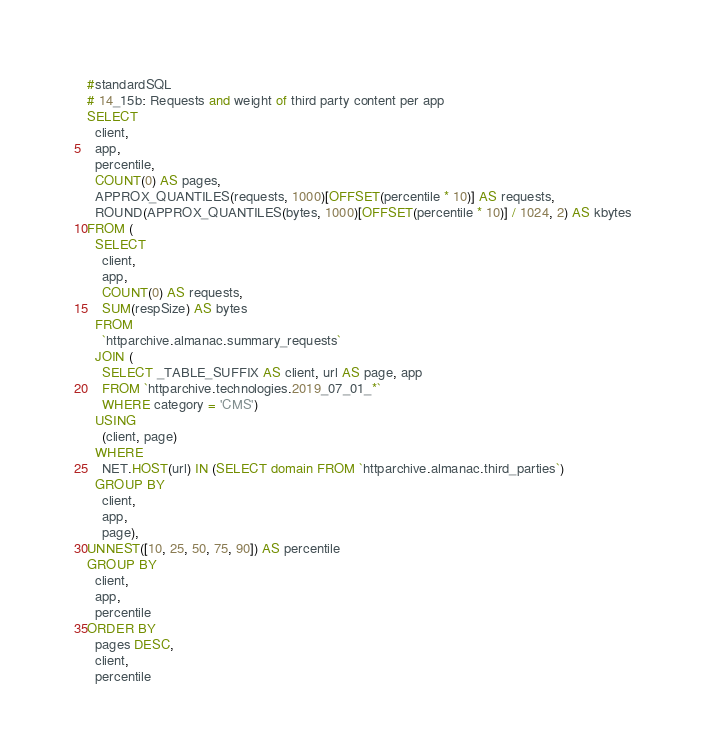Convert code to text. <code><loc_0><loc_0><loc_500><loc_500><_SQL_>#standardSQL
# 14_15b: Requests and weight of third party content per app
SELECT
  client,
  app,
  percentile,
  COUNT(0) AS pages,
  APPROX_QUANTILES(requests, 1000)[OFFSET(percentile * 10)] AS requests,
  ROUND(APPROX_QUANTILES(bytes, 1000)[OFFSET(percentile * 10)] / 1024, 2) AS kbytes
FROM (
  SELECT
    client,
    app,
    COUNT(0) AS requests,
    SUM(respSize) AS bytes
  FROM
    `httparchive.almanac.summary_requests`
  JOIN (
    SELECT _TABLE_SUFFIX AS client, url AS page, app
    FROM `httparchive.technologies.2019_07_01_*`
    WHERE category = 'CMS')
  USING
    (client, page)
  WHERE
    NET.HOST(url) IN (SELECT domain FROM `httparchive.almanac.third_parties`)
  GROUP BY
    client,
    app,
    page),
UNNEST([10, 25, 50, 75, 90]) AS percentile
GROUP BY
  client,
  app,
  percentile
ORDER BY
  pages DESC,
  client,
  percentile</code> 